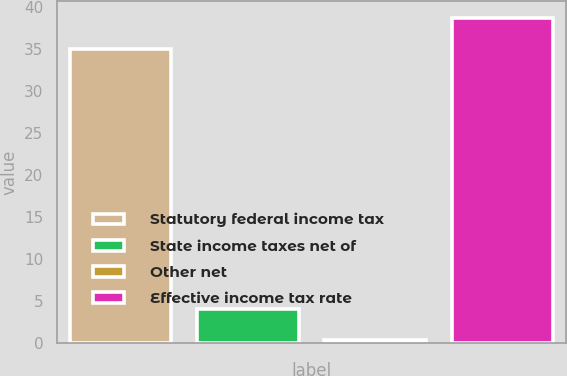<chart> <loc_0><loc_0><loc_500><loc_500><bar_chart><fcel>Statutory federal income tax<fcel>State income taxes net of<fcel>Other net<fcel>Effective income tax rate<nl><fcel>35<fcel>4.07<fcel>0.3<fcel>38.77<nl></chart> 